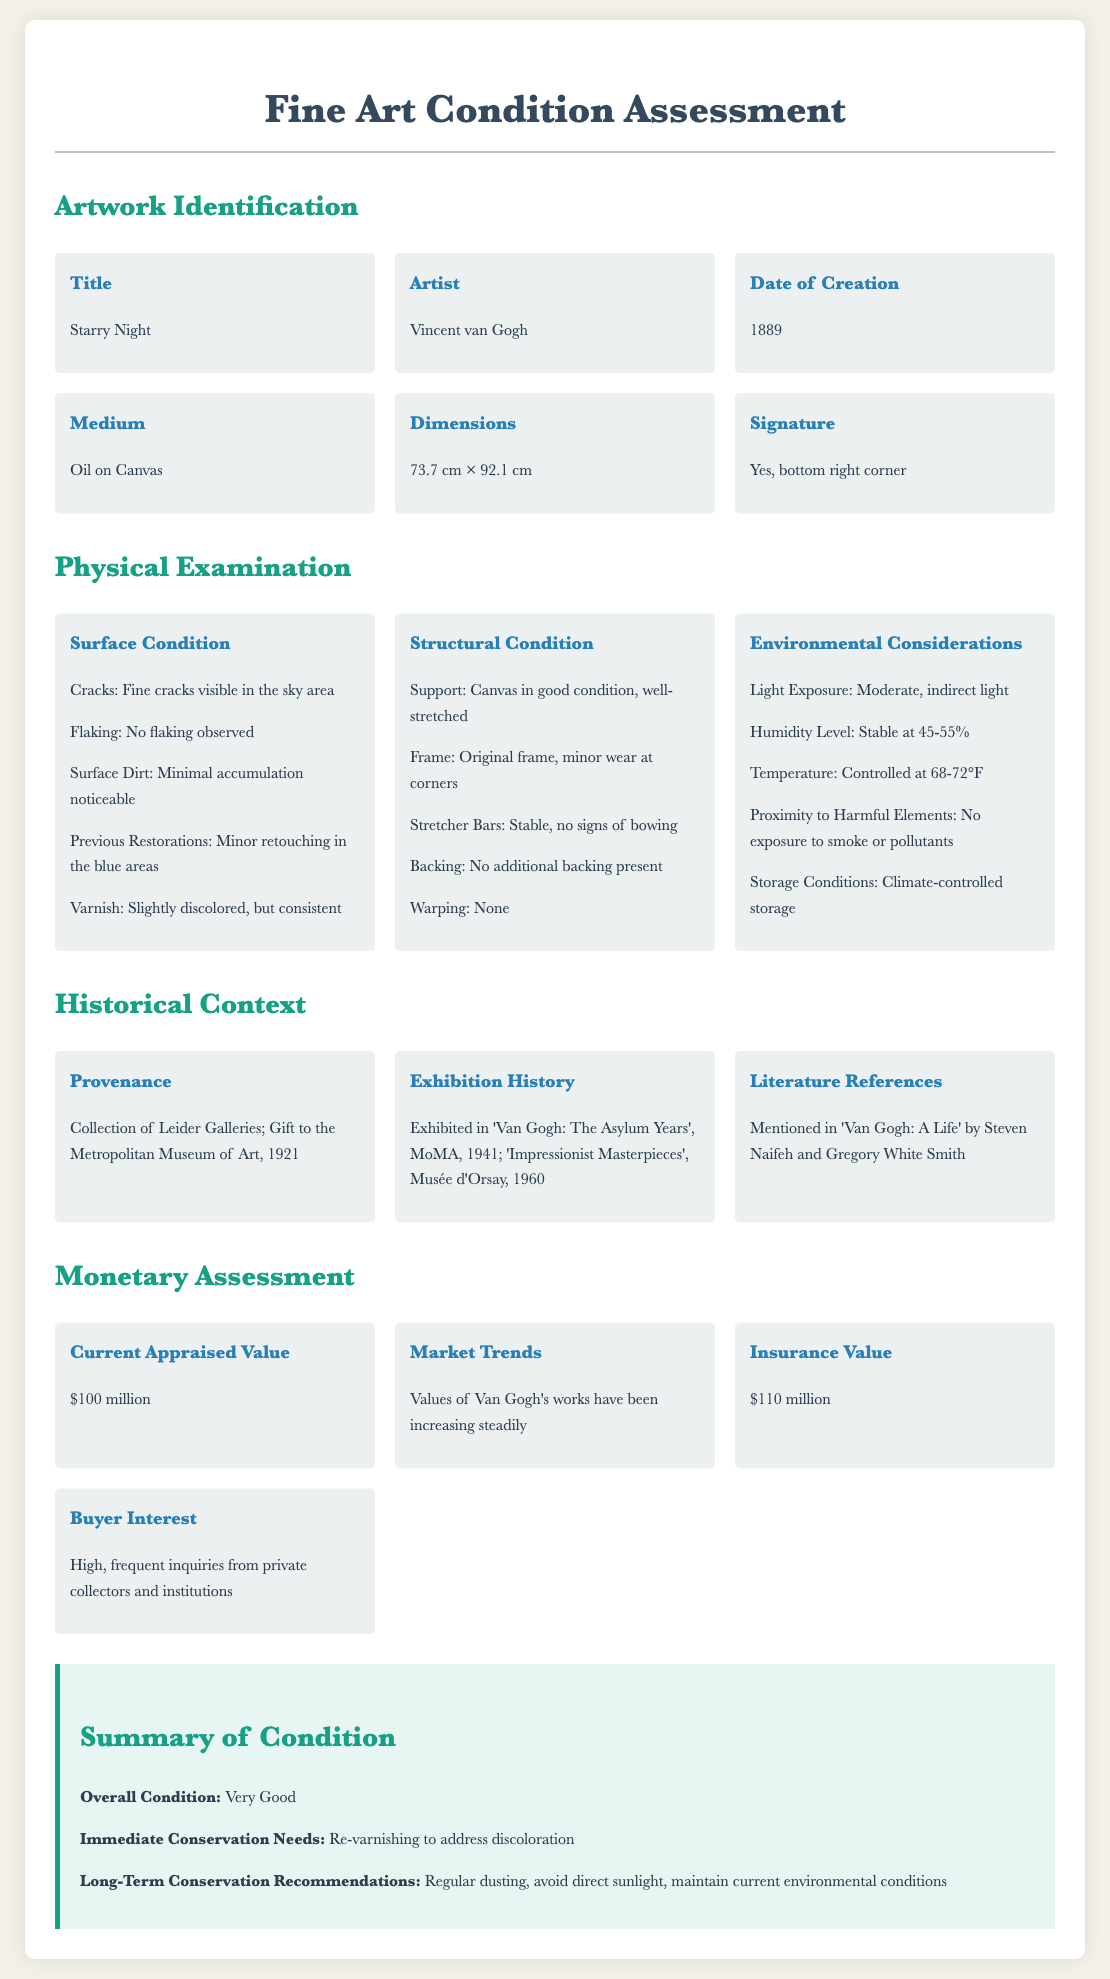what is the title of the artwork? The title of the artwork is mentioned in the Artwork Identification section.
Answer: Starry Night who is the artist of the artwork? The artist is listed in the Artwork Identification section of the document.
Answer: Vincent van Gogh what is the date of creation of the artwork? The date of creation is specified in the Artwork Identification section.
Answer: 1889 what is the current appraised value of the artwork? The current appraised value is indicated in the Monetary Assessment section.
Answer: $100 million what is the immediate conservation need for the artwork? Immediate conservation needs are outlined in the Summary of Condition section.
Answer: Re-varnishing to address discoloration what has been observed in the surface condition of the artwork? The surface condition details can be found in the Physical Examination section, specifically under Surface Condition.
Answer: Fine cracks visible in the sky area what is the environmental humidity level at which the artwork is stored? The humidity level is specified in the Environmental Considerations part of the Physical Examination section.
Answer: 45-55% what is the exhibition history of the artwork? The exhibition history is detailed in the Historical Context section, listing past exhibitions.
Answer: 'Van Gogh: The Asylum Years', MoMA, 1941; 'Impressionist Masterpieces', Musée d'Orsay, 1960 how is the frame of the artwork described? The condition of the frame is mentioned under Structural Condition in the Physical Examination section.
Answer: Original frame, minor wear at corners 